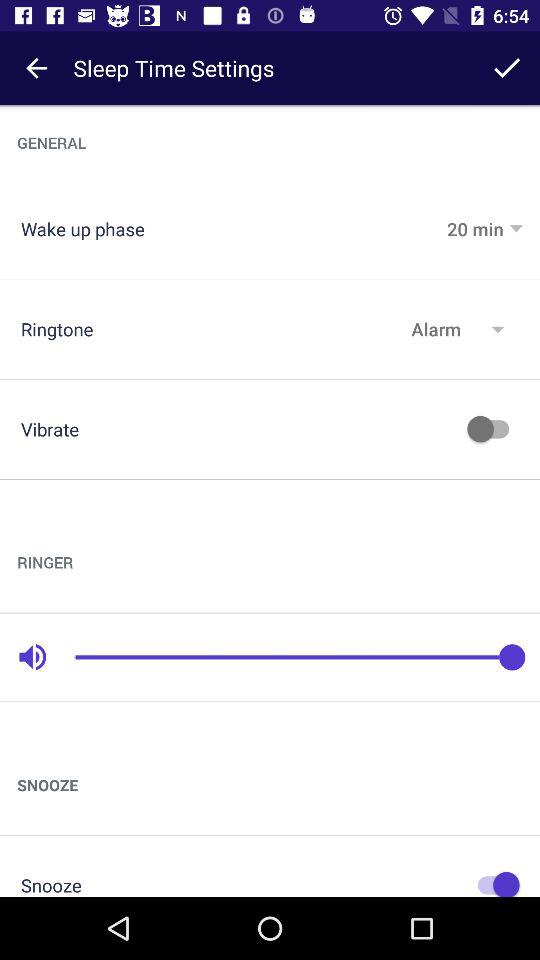Which ringtone is selected? The selected ringtone is "Alarm". 